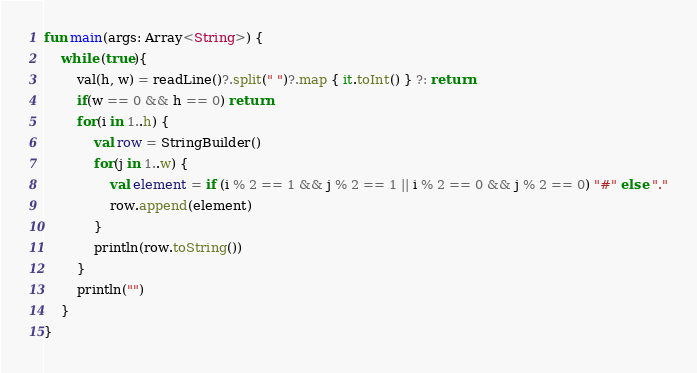Convert code to text. <code><loc_0><loc_0><loc_500><loc_500><_Kotlin_>fun main(args: Array<String>) {
    while (true){
        val(h, w) = readLine()?.split(" ")?.map { it.toInt() } ?: return
        if(w == 0 && h == 0) return
        for(i in 1..h) {
            val row = StringBuilder()
            for(j in 1..w) {
                val element = if (i % 2 == 1 && j % 2 == 1 || i % 2 == 0 && j % 2 == 0) "#" else "."
                row.append(element)
            }
            println(row.toString())
        }
        println("")
    }
}
</code> 